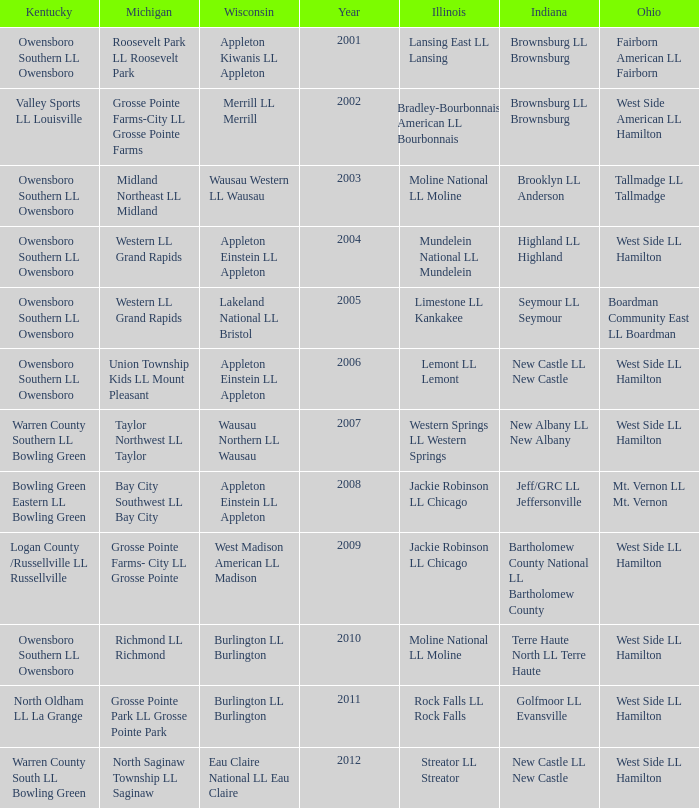What was the little league team from Michigan when the little league team from Indiana was Terre Haute North LL Terre Haute?  Richmond LL Richmond. 